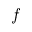Convert formula to latex. <formula><loc_0><loc_0><loc_500><loc_500>f</formula> 